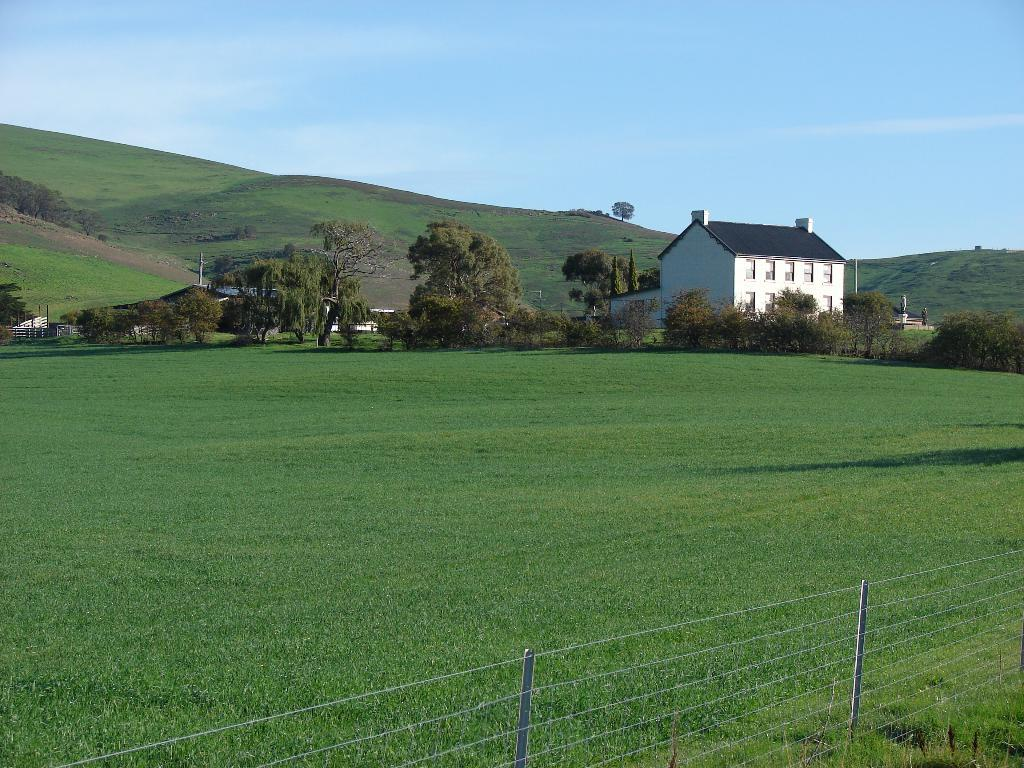Where was the image taken? The image was clicked outside. What can be seen in the middle of the image? There are trees and a building in the middle of the image. What is visible at the top of the image? The sky is visible at the top of the image. What type of vegetation is at the bottom of the image? There is grass at the bottom of the image. Can you see a squirrel gripping the tree in the image? There is no squirrel present in the image, and therefore no gripping can be observed. 